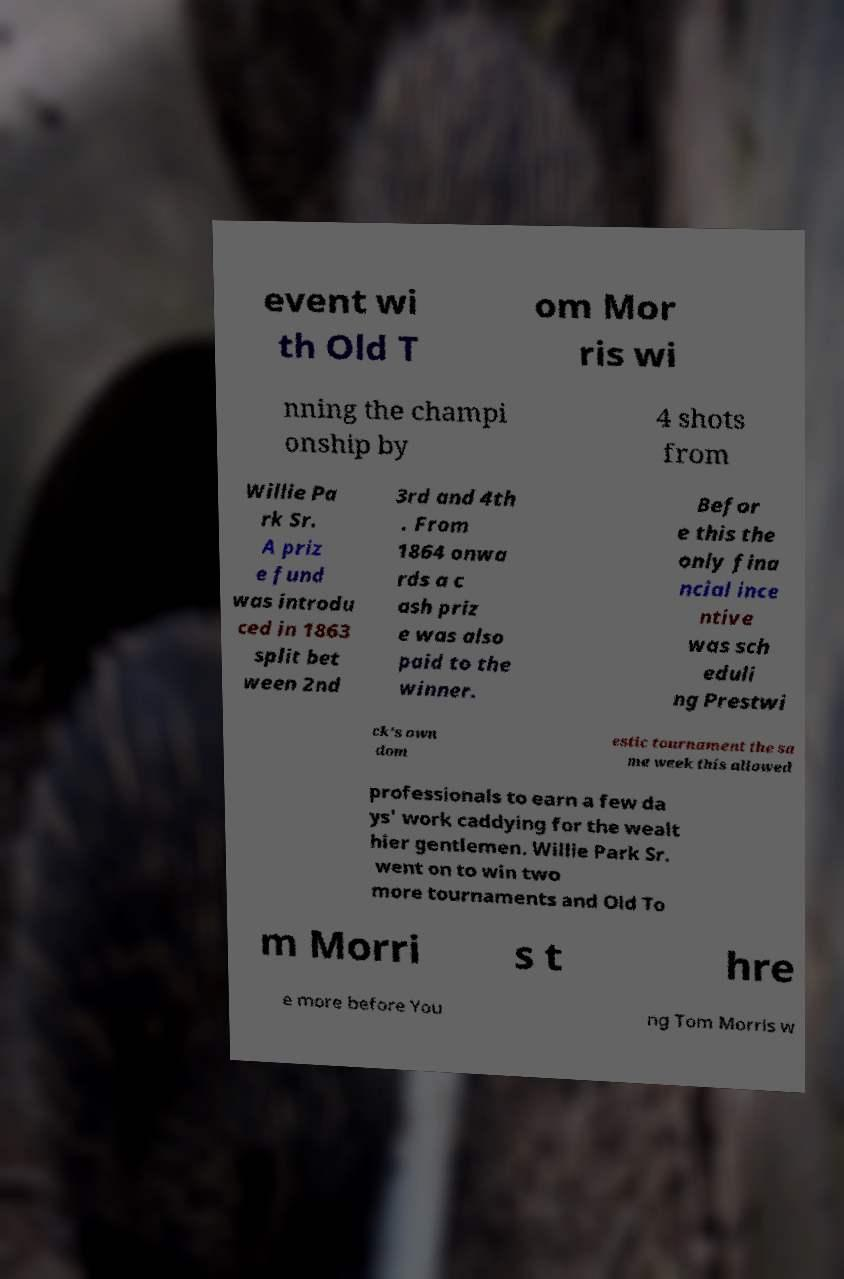I need the written content from this picture converted into text. Can you do that? event wi th Old T om Mor ris wi nning the champi onship by 4 shots from Willie Pa rk Sr. A priz e fund was introdu ced in 1863 split bet ween 2nd 3rd and 4th . From 1864 onwa rds a c ash priz e was also paid to the winner. Befor e this the only fina ncial ince ntive was sch eduli ng Prestwi ck's own dom estic tournament the sa me week this allowed professionals to earn a few da ys' work caddying for the wealt hier gentlemen. Willie Park Sr. went on to win two more tournaments and Old To m Morri s t hre e more before You ng Tom Morris w 